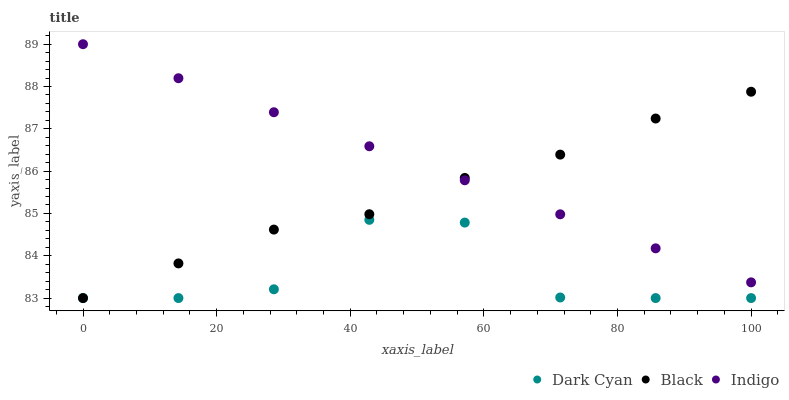Does Dark Cyan have the minimum area under the curve?
Answer yes or no. Yes. Does Indigo have the maximum area under the curve?
Answer yes or no. Yes. Does Black have the minimum area under the curve?
Answer yes or no. No. Does Black have the maximum area under the curve?
Answer yes or no. No. Is Indigo the smoothest?
Answer yes or no. Yes. Is Dark Cyan the roughest?
Answer yes or no. Yes. Is Black the smoothest?
Answer yes or no. No. Is Black the roughest?
Answer yes or no. No. Does Dark Cyan have the lowest value?
Answer yes or no. Yes. Does Indigo have the lowest value?
Answer yes or no. No. Does Indigo have the highest value?
Answer yes or no. Yes. Does Black have the highest value?
Answer yes or no. No. Is Dark Cyan less than Indigo?
Answer yes or no. Yes. Is Indigo greater than Dark Cyan?
Answer yes or no. Yes. Does Indigo intersect Black?
Answer yes or no. Yes. Is Indigo less than Black?
Answer yes or no. No. Is Indigo greater than Black?
Answer yes or no. No. Does Dark Cyan intersect Indigo?
Answer yes or no. No. 